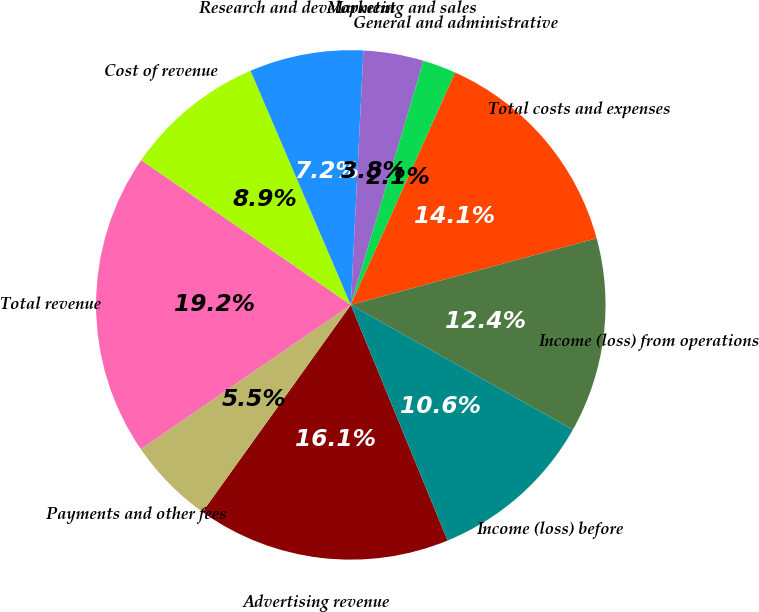<chart> <loc_0><loc_0><loc_500><loc_500><pie_chart><fcel>Advertising revenue<fcel>Payments and other fees<fcel>Total revenue<fcel>Cost of revenue<fcel>Research and development<fcel>Marketing and sales<fcel>General and administrative<fcel>Total costs and expenses<fcel>Income (loss) from operations<fcel>Income (loss) before<nl><fcel>16.1%<fcel>5.53%<fcel>19.2%<fcel>8.94%<fcel>7.23%<fcel>3.82%<fcel>2.11%<fcel>14.07%<fcel>12.36%<fcel>10.65%<nl></chart> 